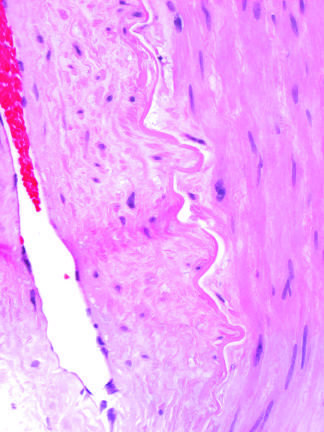how is vascular changes and fibrosis of salivary glands produced?
Answer the question using a single word or phrase. By radiation therapy of the neck region 